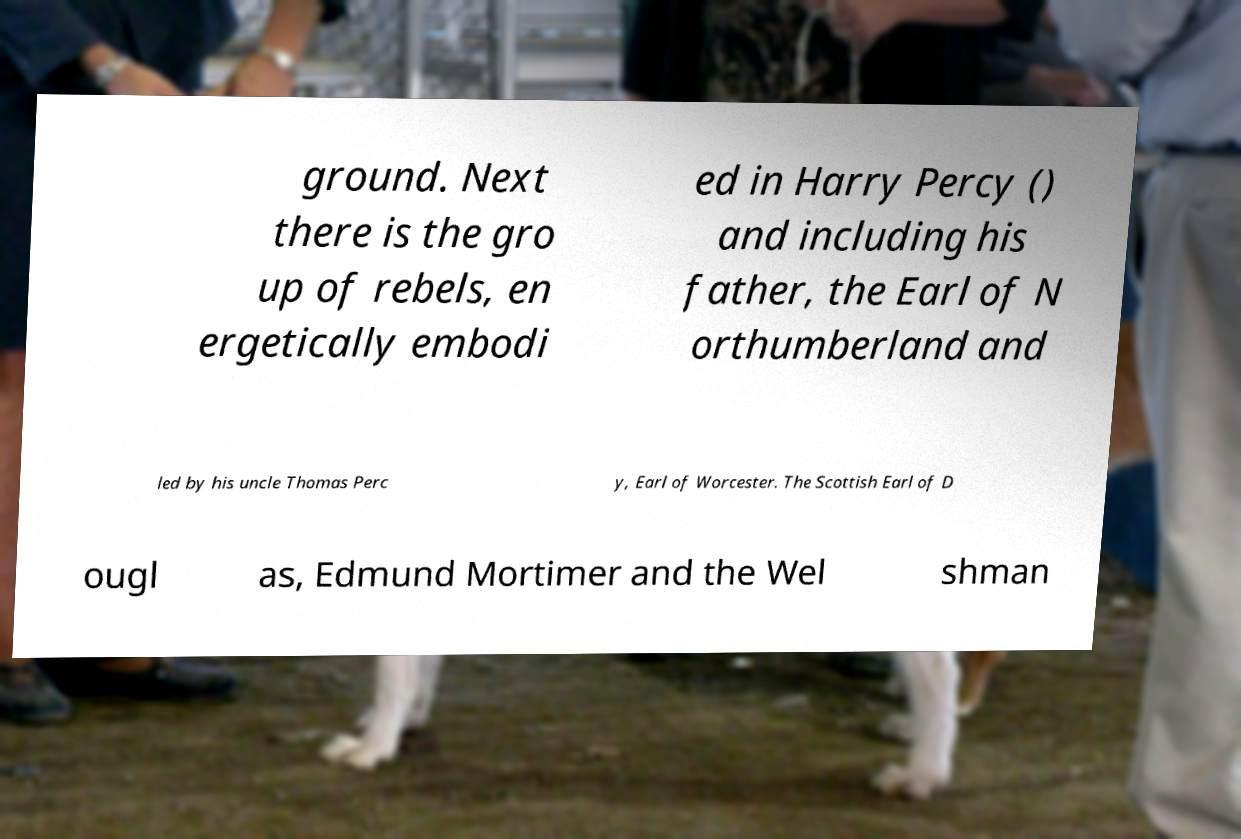Can you read and provide the text displayed in the image?This photo seems to have some interesting text. Can you extract and type it out for me? ground. Next there is the gro up of rebels, en ergetically embodi ed in Harry Percy () and including his father, the Earl of N orthumberland and led by his uncle Thomas Perc y, Earl of Worcester. The Scottish Earl of D ougl as, Edmund Mortimer and the Wel shman 